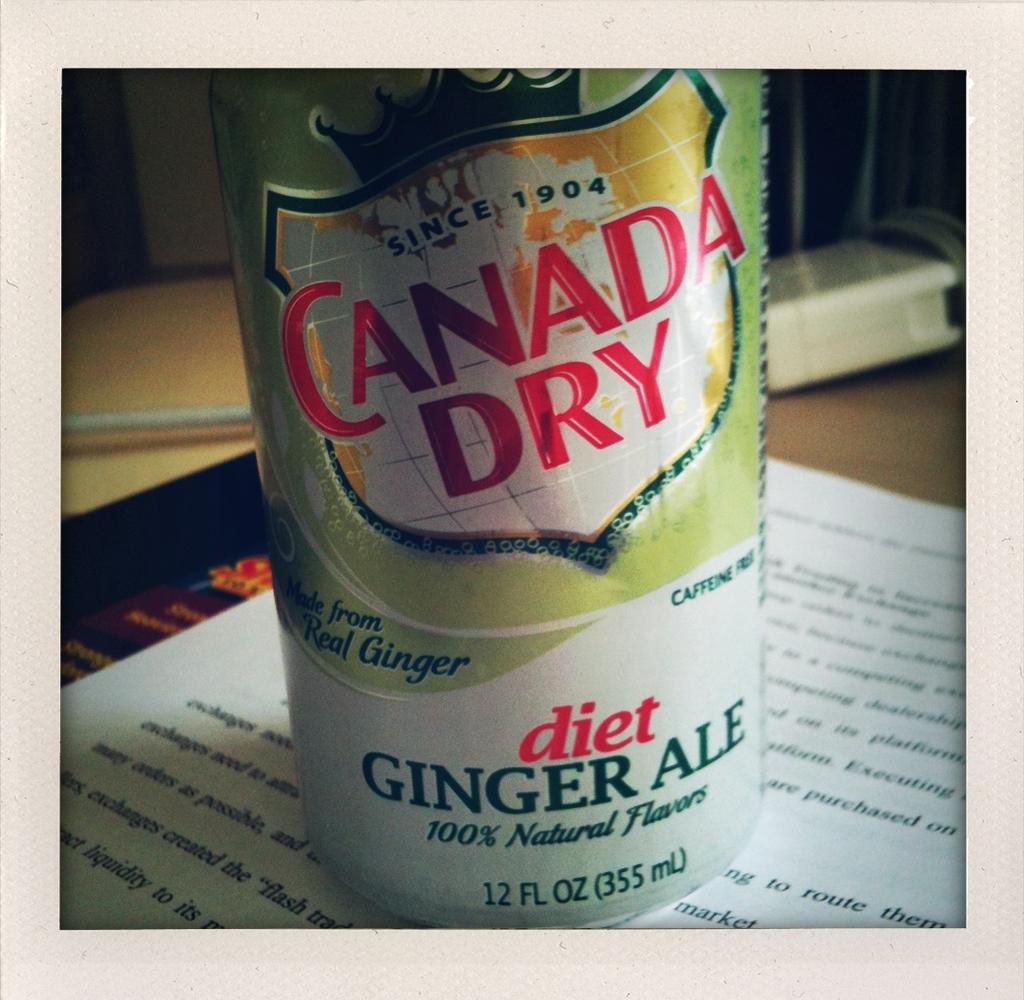What type of drink is this?
Your answer should be very brief. Diet ginger ale. 